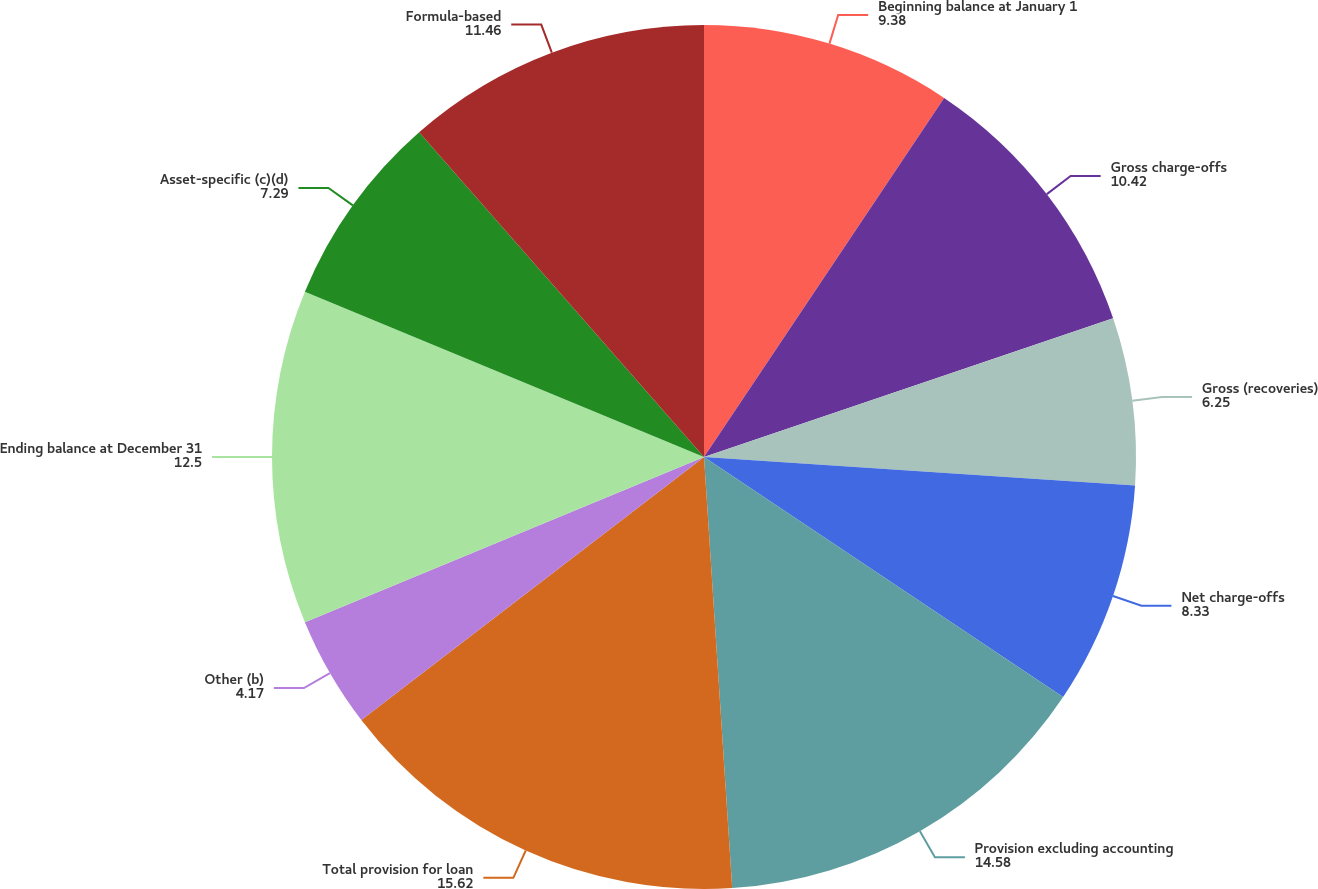Convert chart to OTSL. <chart><loc_0><loc_0><loc_500><loc_500><pie_chart><fcel>Beginning balance at January 1<fcel>Gross charge-offs<fcel>Gross (recoveries)<fcel>Net charge-offs<fcel>Provision excluding accounting<fcel>Total provision for loan<fcel>Other (b)<fcel>Ending balance at December 31<fcel>Asset-specific (c)(d)<fcel>Formula-based<nl><fcel>9.38%<fcel>10.42%<fcel>6.25%<fcel>8.33%<fcel>14.58%<fcel>15.62%<fcel>4.17%<fcel>12.5%<fcel>7.29%<fcel>11.46%<nl></chart> 